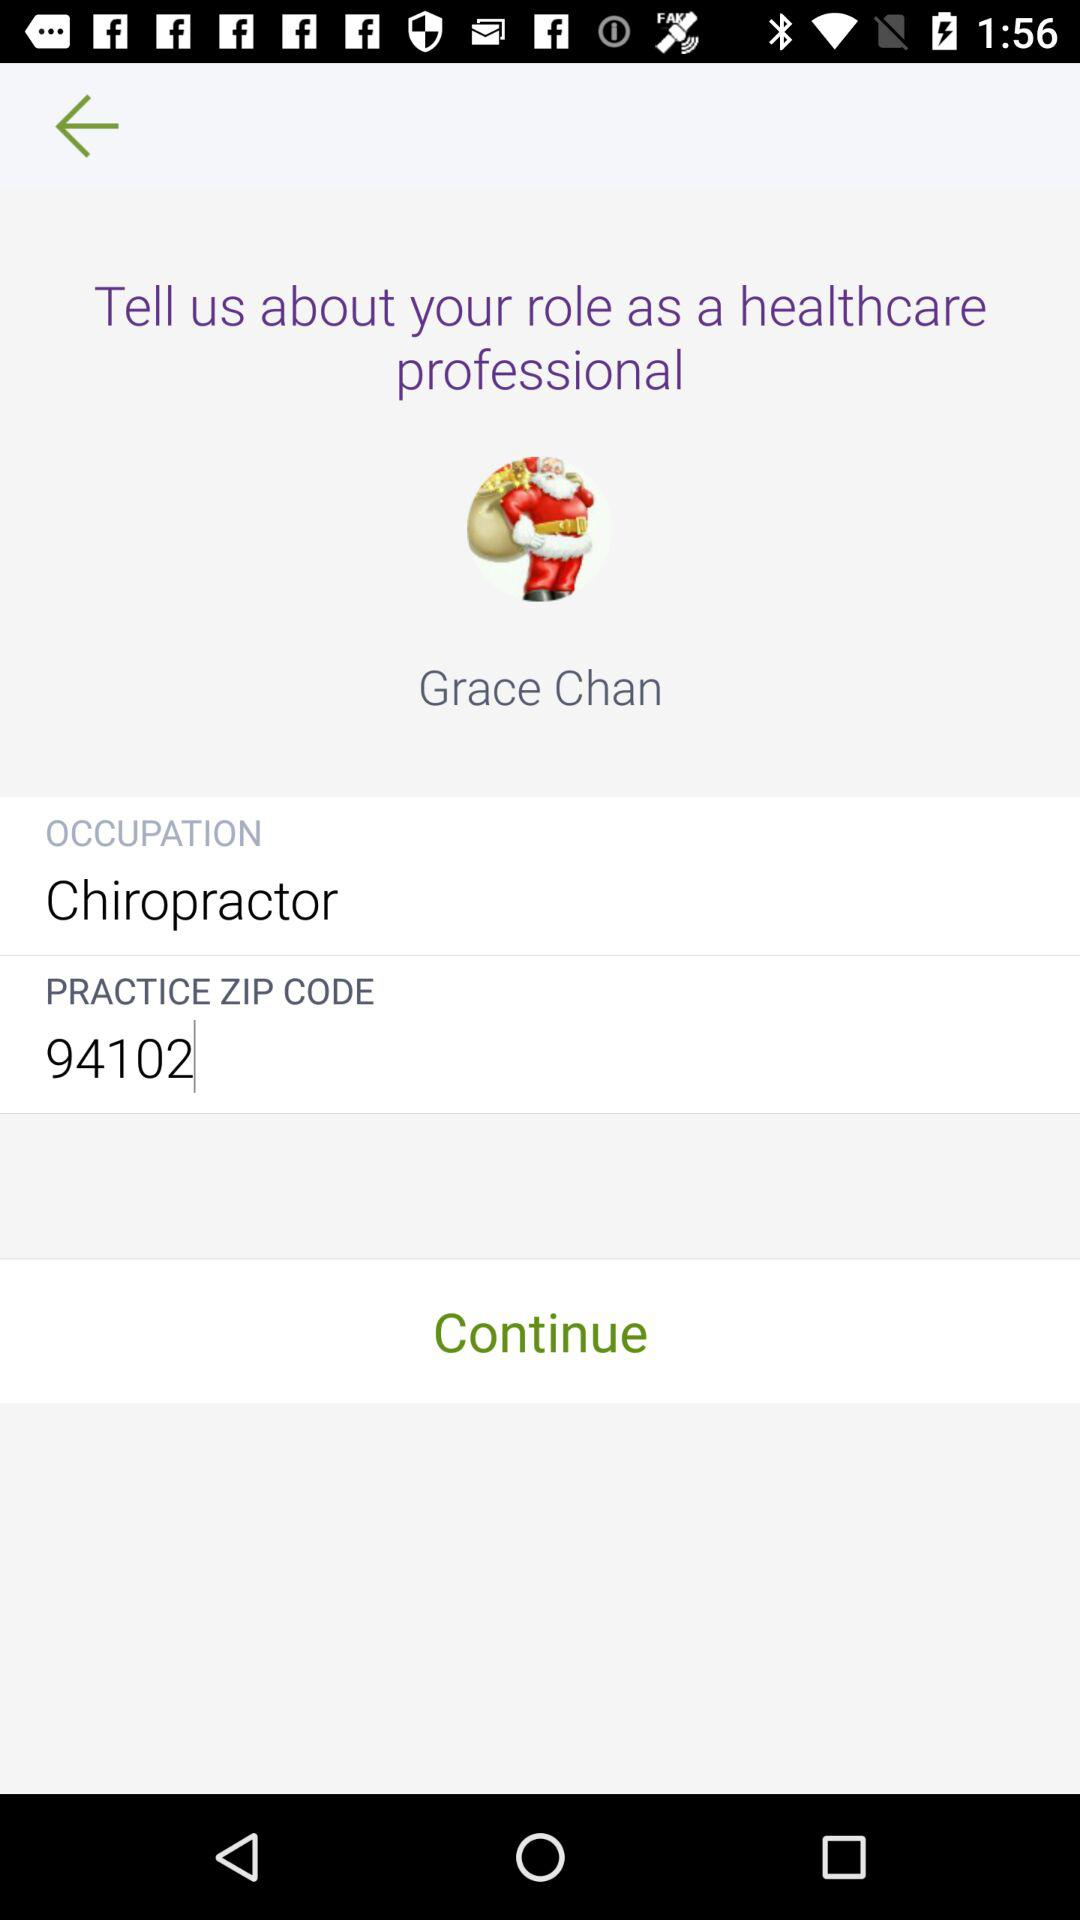What is the occupation? The occupation is chiropractor. 